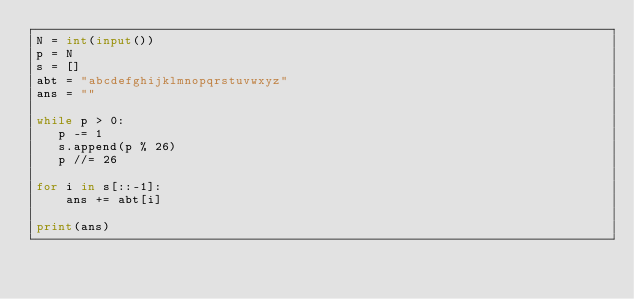Convert code to text. <code><loc_0><loc_0><loc_500><loc_500><_Python_>N = int(input())
p = N
s = []
abt = "abcdefghijklmnopqrstuvwxyz"
ans = ""

while p > 0:
   p -= 1
   s.append(p % 26)
   p //= 26

for i in s[::-1]:
    ans += abt[i]

print(ans)
</code> 